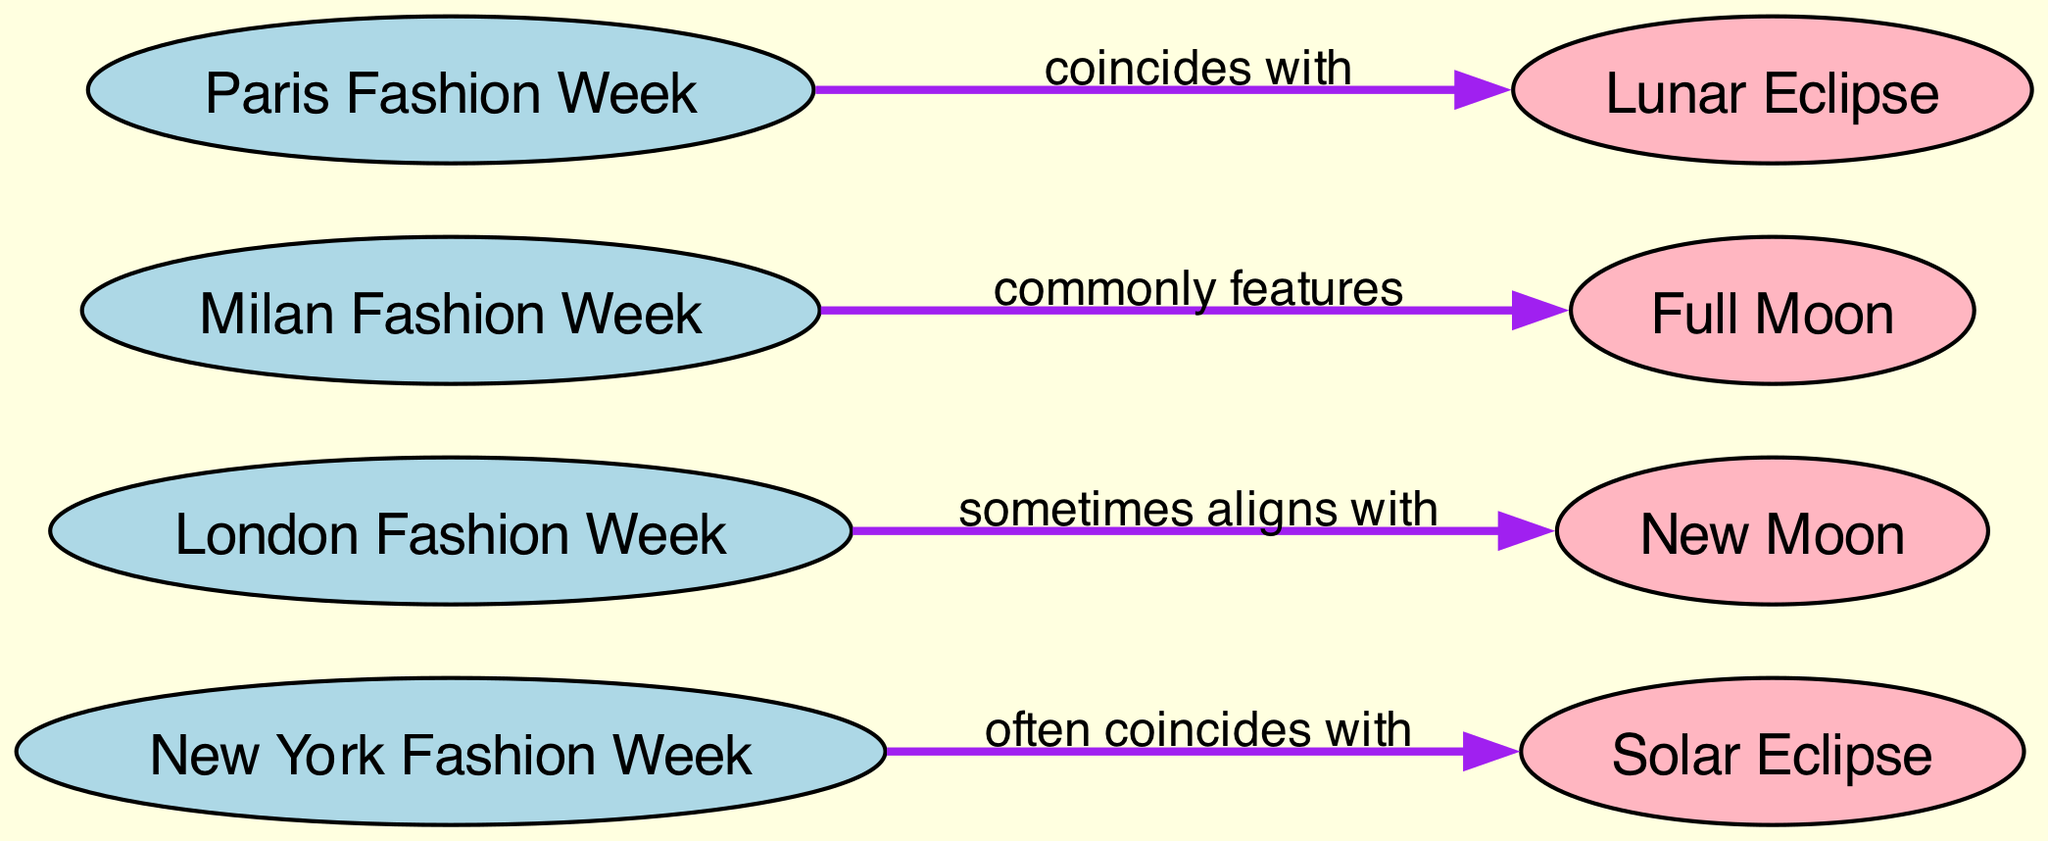What is the total number of nodes in the diagram? The diagram lists out the nodes for different fashion weeks and astronomical events. By counting each unique entry under "nodes", we find there are eight distinct nodes.
Answer: 8 Which fashion week is associated with a solar eclipse? By examining the edges of the diagram, we see that New York Fashion Week is linked to the solar eclipse. The edge indicates they "often coincide."
Answer: New York Fashion Week What event does London Fashion Week sometimes align with? The diagram illustrates that London Fashion Week is connected to the new moon phase. Thus, it indicates this alignment under the edge label.
Answer: New Moon Which fashion week commonly features designs aligned with the full moon? Looking at the diagram, Milan Fashion Week is stated to align with full moon energy, so it is described as commonly featuring this alignment.
Answer: Milan Fashion Week How many edges are there connecting fashion weeks to astronomical events? The edges specifically denote relationships between fashion weeks and cosmic events. There are four edges listed in the diagram as connections.
Answer: 4 What cosmic event coincides with Paris Fashion Week? According to the diagram, the edge from Paris Fashion Week states it coincides with lunar eclipses, highlighting this specific relationship.
Answer: Lunar Eclipse Which fashion week overlaps with the lunar eclipse? Examining the edges indicates that Paris Fashion Week is the one that overlaps with the lunar eclipses, explicitly marked on the diagram.
Answer: Paris Fashion Week What is the primary theme represented by the nodes and edges in this diagram? The diagram connects major fashion events with astronomical occurrences, showing cosmic influences on fashion trends signifies that astrology might affect timelines of styles.
Answer: Cosmic Influences on Couture 